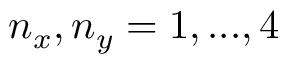<formula> <loc_0><loc_0><loc_500><loc_500>n _ { x } , n _ { y } = 1 , \dots , 4</formula> 